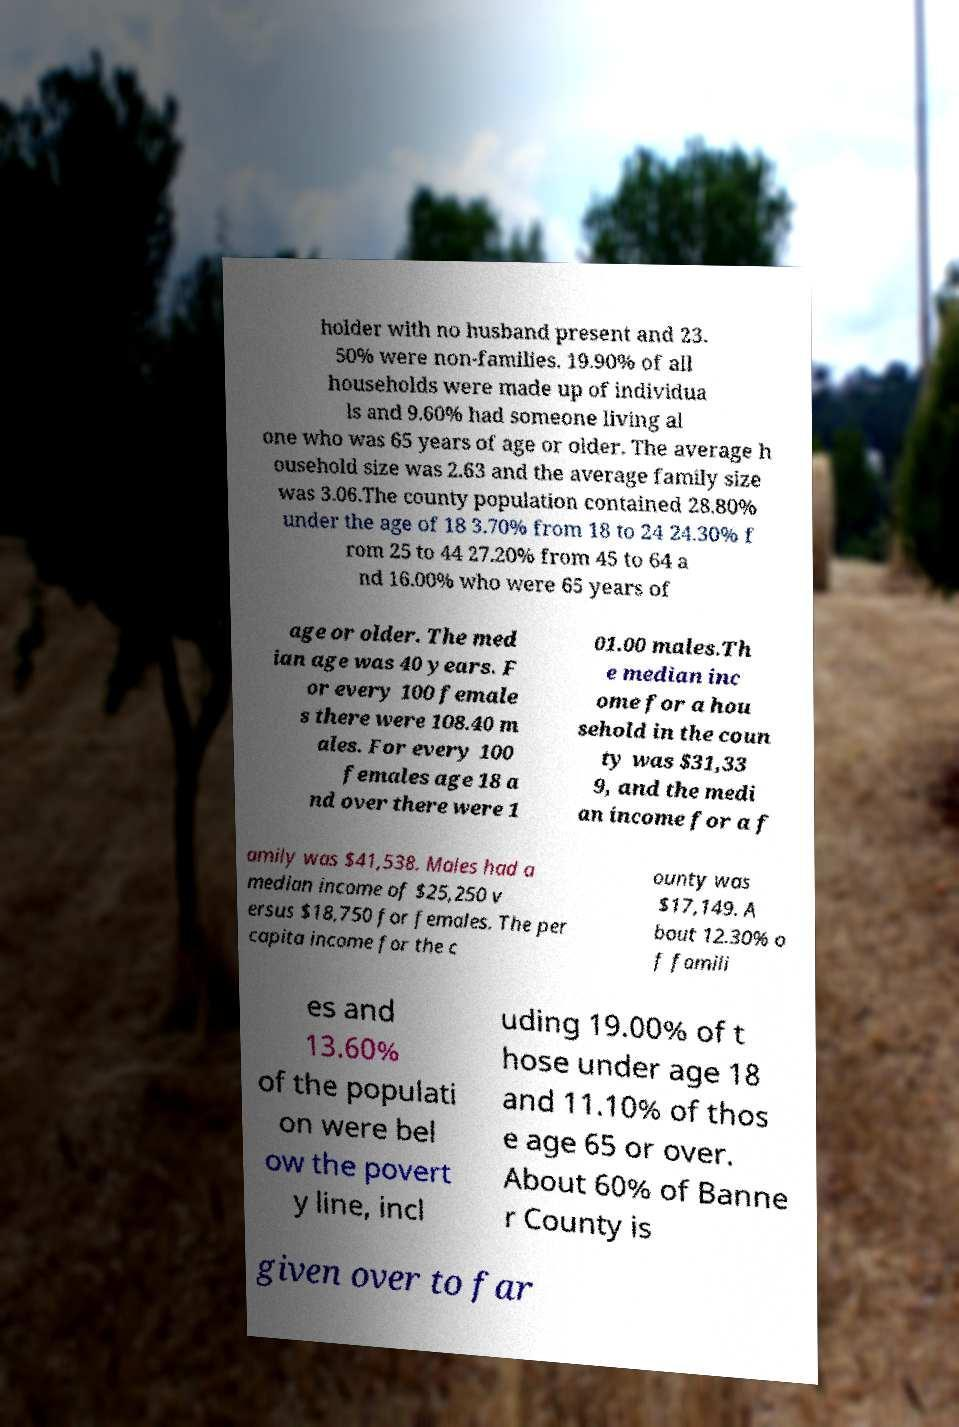Can you accurately transcribe the text from the provided image for me? holder with no husband present and 23. 50% were non-families. 19.90% of all households were made up of individua ls and 9.60% had someone living al one who was 65 years of age or older. The average h ousehold size was 2.63 and the average family size was 3.06.The county population contained 28.80% under the age of 18 3.70% from 18 to 24 24.30% f rom 25 to 44 27.20% from 45 to 64 a nd 16.00% who were 65 years of age or older. The med ian age was 40 years. F or every 100 female s there were 108.40 m ales. For every 100 females age 18 a nd over there were 1 01.00 males.Th e median inc ome for a hou sehold in the coun ty was $31,33 9, and the medi an income for a f amily was $41,538. Males had a median income of $25,250 v ersus $18,750 for females. The per capita income for the c ounty was $17,149. A bout 12.30% o f famili es and 13.60% of the populati on were bel ow the povert y line, incl uding 19.00% of t hose under age 18 and 11.10% of thos e age 65 or over. About 60% of Banne r County is given over to far 